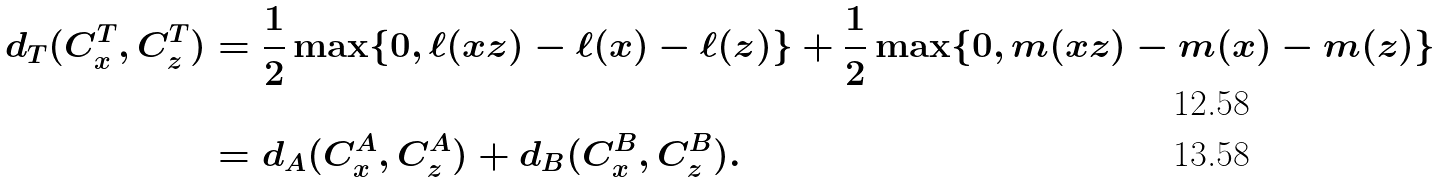<formula> <loc_0><loc_0><loc_500><loc_500>d _ { T } ( C _ { x } ^ { T } , C _ { z } ^ { T } ) & = \frac { 1 } { 2 } \max \{ 0 , \ell ( x z ) - \ell ( x ) - \ell ( z ) \} + \frac { 1 } { 2 } \max \{ 0 , m ( x z ) - m ( x ) - m ( z ) \} \\ & = d _ { A } ( C _ { x } ^ { A } , C _ { z } ^ { A } ) + d _ { B } ( C _ { x } ^ { B } , C _ { z } ^ { B } ) .</formula> 